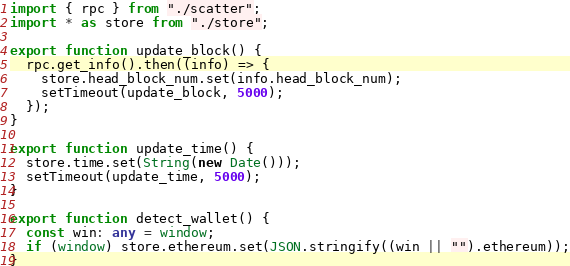<code> <loc_0><loc_0><loc_500><loc_500><_TypeScript_>import { rpc } from "./scatter";
import * as store from "./store";

export function update_block() {
  rpc.get_info().then((info) => {
    store.head_block_num.set(info.head_block_num);
    setTimeout(update_block, 5000);
  });
}

export function update_time() {
  store.time.set(String(new Date()));
  setTimeout(update_time, 5000);
}

export function detect_wallet() {
  const win: any = window;
  if (window) store.ethereum.set(JSON.stringify((win || "").ethereum));
}
</code> 